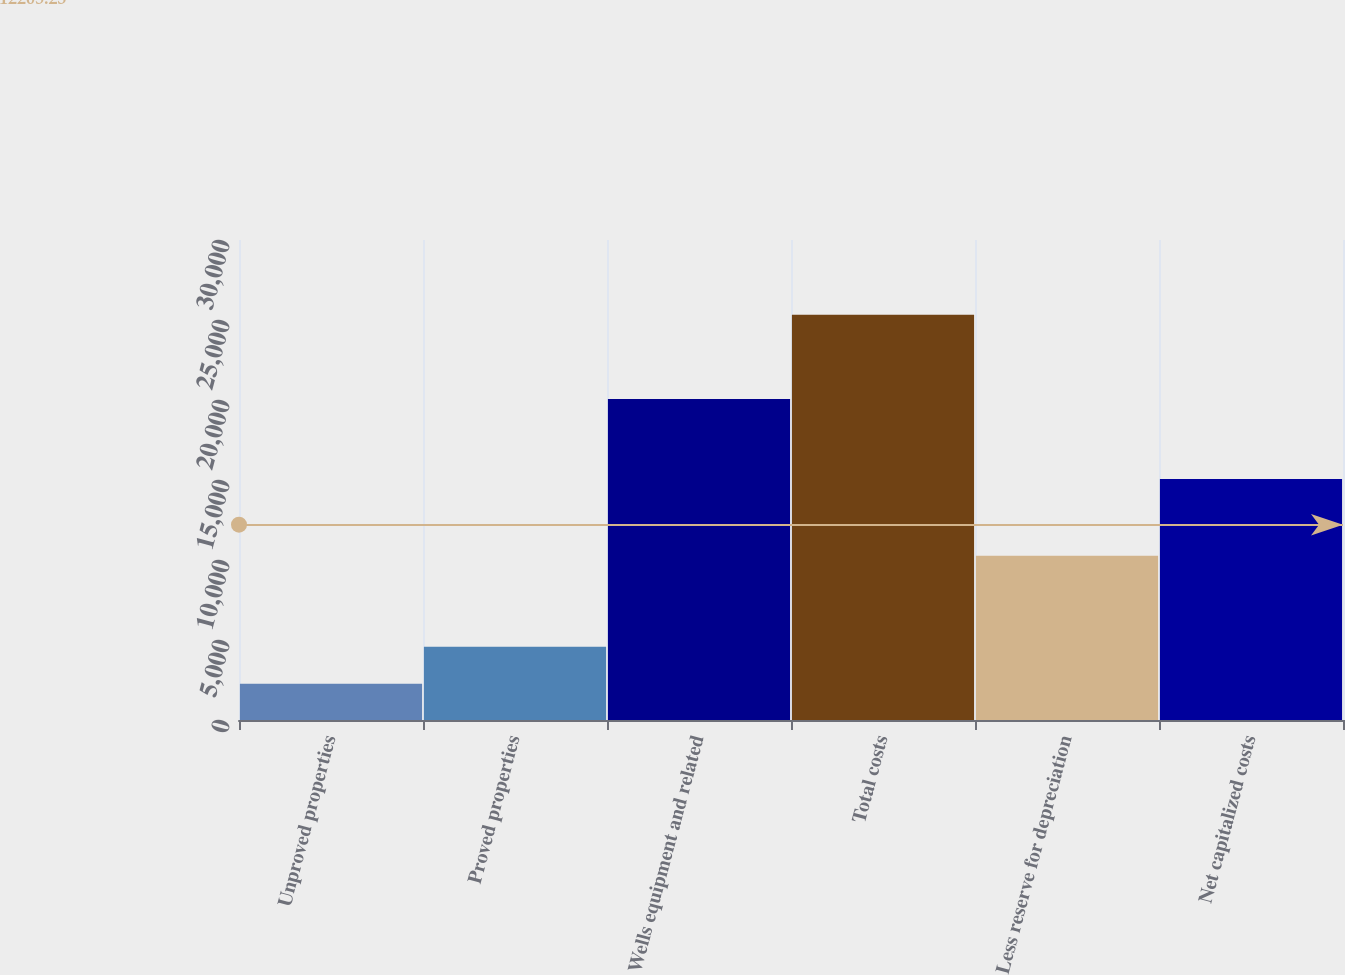Convert chart to OTSL. <chart><loc_0><loc_0><loc_500><loc_500><bar_chart><fcel>Unproved properties<fcel>Proved properties<fcel>Wells equipment and related<fcel>Total costs<fcel>Less reserve for depreciation<fcel>Net capitalized costs<nl><fcel>2265<fcel>4571.7<fcel>20058<fcel>25332<fcel>10269<fcel>15063<nl></chart> 